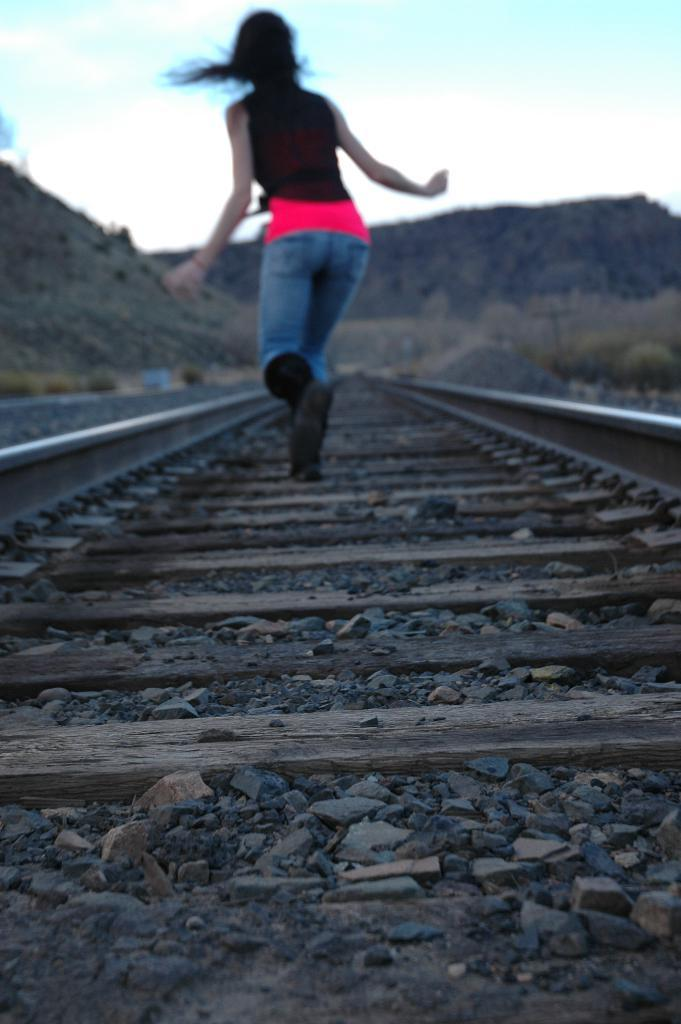Who is the main subject in the image? There is a woman in the image. What is the woman doing in the image? The woman is running. Where is the woman running in the image? The woman is on a railway track. What can be seen on either side of the railway track? There are plants on either side of the railway track. What is visible in the background of the image? There are mountains visible in the image. What type of lead is the woman using to guide her running in the image? There is no lead present in the image, and the woman is not using any guidance to run. 